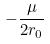Convert formula to latex. <formula><loc_0><loc_0><loc_500><loc_500>- \frac { \mu } { 2 r _ { 0 } }</formula> 